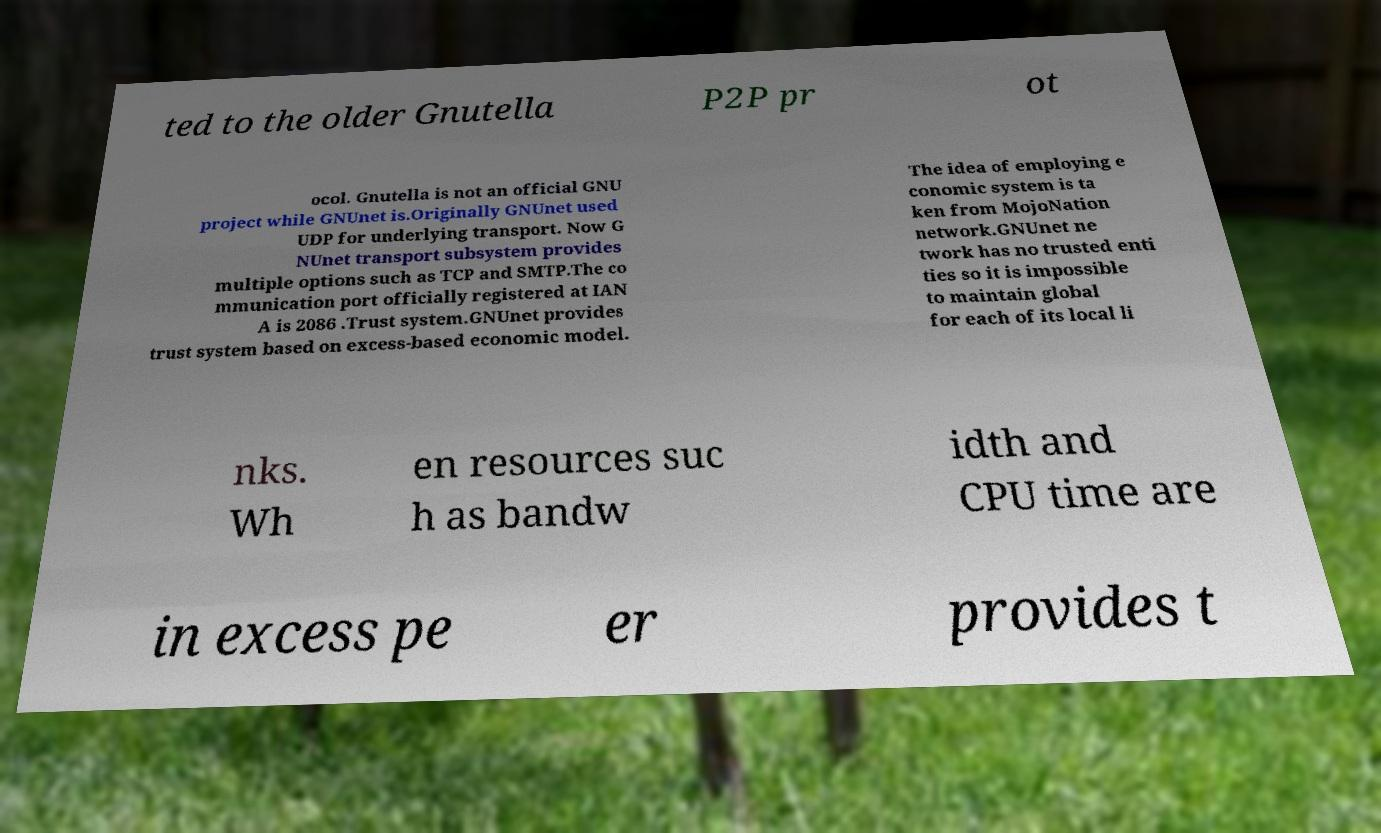Please identify and transcribe the text found in this image. ted to the older Gnutella P2P pr ot ocol. Gnutella is not an official GNU project while GNUnet is.Originally GNUnet used UDP for underlying transport. Now G NUnet transport subsystem provides multiple options such as TCP and SMTP.The co mmunication port officially registered at IAN A is 2086 .Trust system.GNUnet provides trust system based on excess-based economic model. The idea of employing e conomic system is ta ken from MojoNation network.GNUnet ne twork has no trusted enti ties so it is impossible to maintain global for each of its local li nks. Wh en resources suc h as bandw idth and CPU time are in excess pe er provides t 